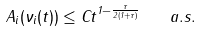Convert formula to latex. <formula><loc_0><loc_0><loc_500><loc_500>A _ { i } ( \nu _ { i } ( t ) ) \leq C t ^ { 1 - \frac { \tau } { 2 ( 1 + \tau ) } } \quad a . s .</formula> 